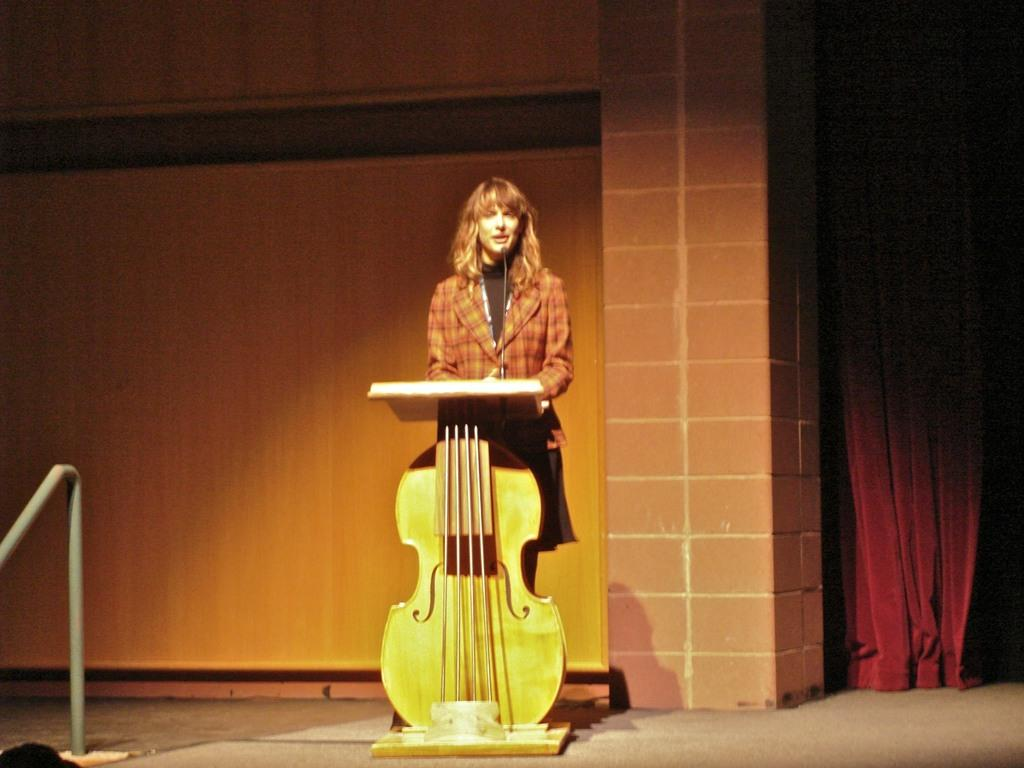Who is present in the image? There is a woman in the image. What is the woman doing in the image? The woman is standing near a podium. Can you describe the podium in the image? The podium is in the shape of a guitar. What can be seen in the background of the image? There is a wall and a red curtain in the background of the image. What type of branch is the woman holding in the image? There is no branch present in the image; the woman is standing near a guitar-shaped podium. 